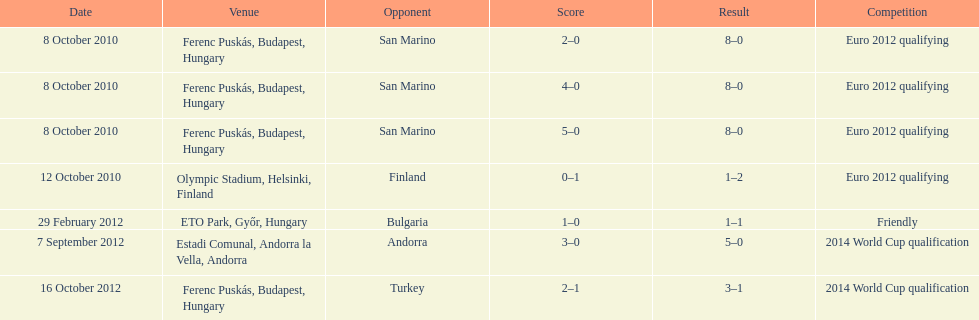Szalai scored only one more international goal against all other countries put together than he did against what one country? San Marino. 